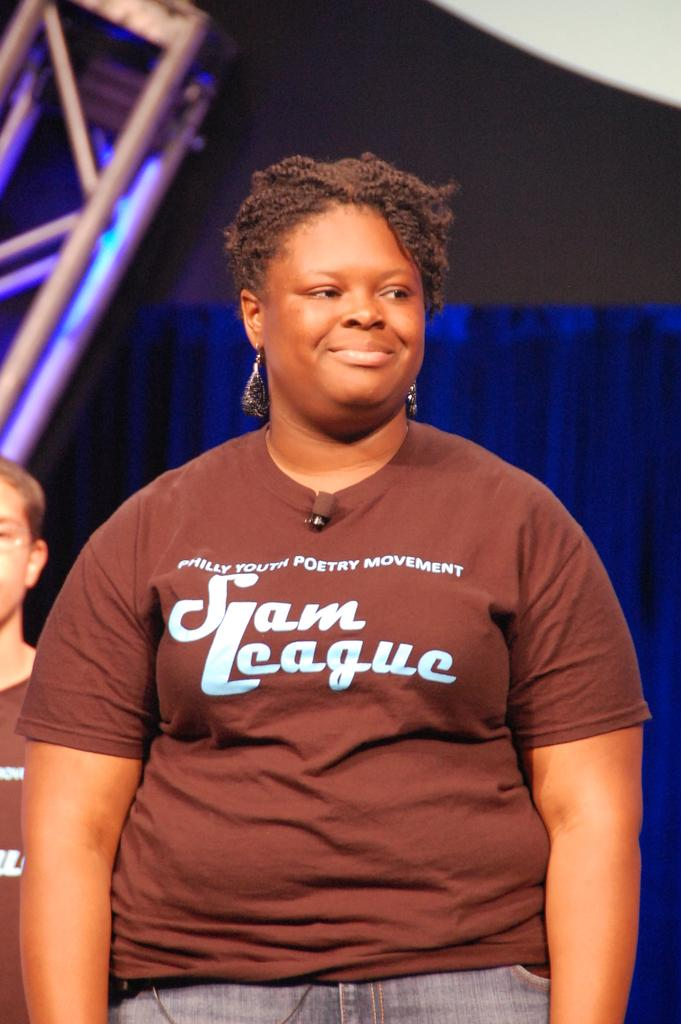<image>
Give a short and clear explanation of the subsequent image. a lady that has the word sam league on her shirt 